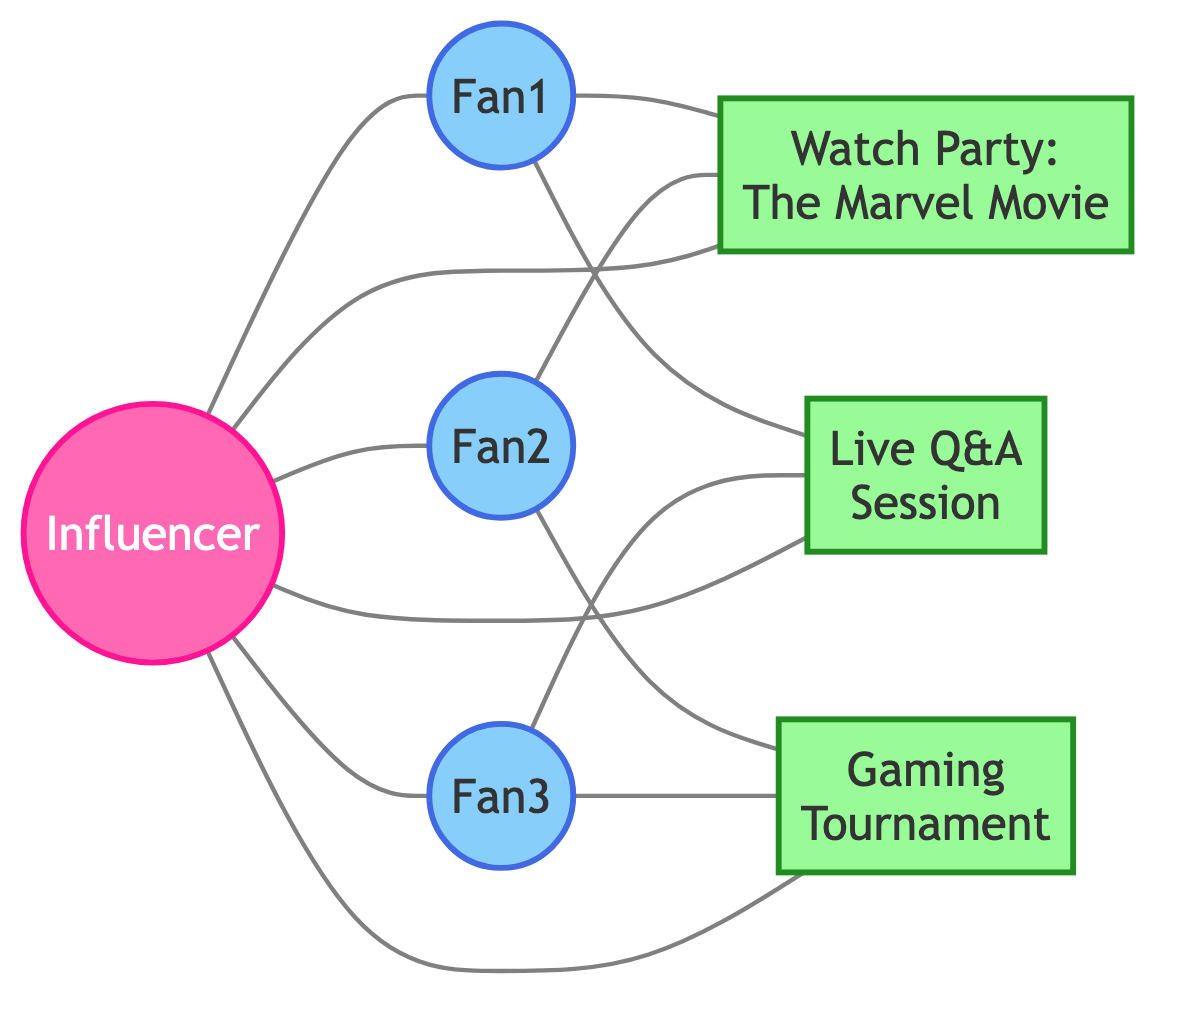What is the total number of nodes in the graph? The nodes in the graph are: Influencer, Fan1, Fan2, Fan3, MultiplexEvent1, MultiplexEvent2, MultiplexEvent3. Counting these gives a total of 7 nodes.
Answer: 7 Which fan attended both the Watch Party and the Live Q&A Session? By examining the edges connecting fans to events, I can see that Fan1 is linked to both MultiplexEvent1 and MultiplexEvent2. Therefore, Fan1 attended both events.
Answer: Fan1 How many events are connected to the Influencer? The edges indicate that Influencer is connected to MultiplexEvent1, MultiplexEvent2, and MultiplexEvent3. This means there are three events connected to the Influencer.
Answer: 3 Which two fans participated in the Gaming Tournament? From the edges, Fan2 and Fan3 are both connected to MultiplexEvent3 (Gaming Tournament). Therefore, they are the two fans who participated in it.
Answer: Fan2 and Fan3 Is there a fan who attended the same events as another fan? If so, who? Analyzing the connections, both Fan1 and Fan2 attended the Watch Party (MultiplexEvent1), meaning they attended the same event.
Answer: Fan1 and Fan2 What is the relationship between Fan3 and the Influencer? The diagram shows an edge connecting Fan3 directly to the Influencer, indicating a direct interaction or relationship between them.
Answer: Direct connection Which event had the most fan interactions? Checking the number of connections (edges) leading to each event: MultiplexEvent1 has 3 (Fan1, Fan2, Influencer), MultiplexEvent2 has 3 (Fan1, Fan3, Influencer), and MultiplexEvent3 has 2 (Fan2, Fan3, Influencer). Both MultiplexEvent1 and MultiplexEvent2 had the most interactions with 3 connections each.
Answer: MultiplexEvent1 and MultiplexEvent2 